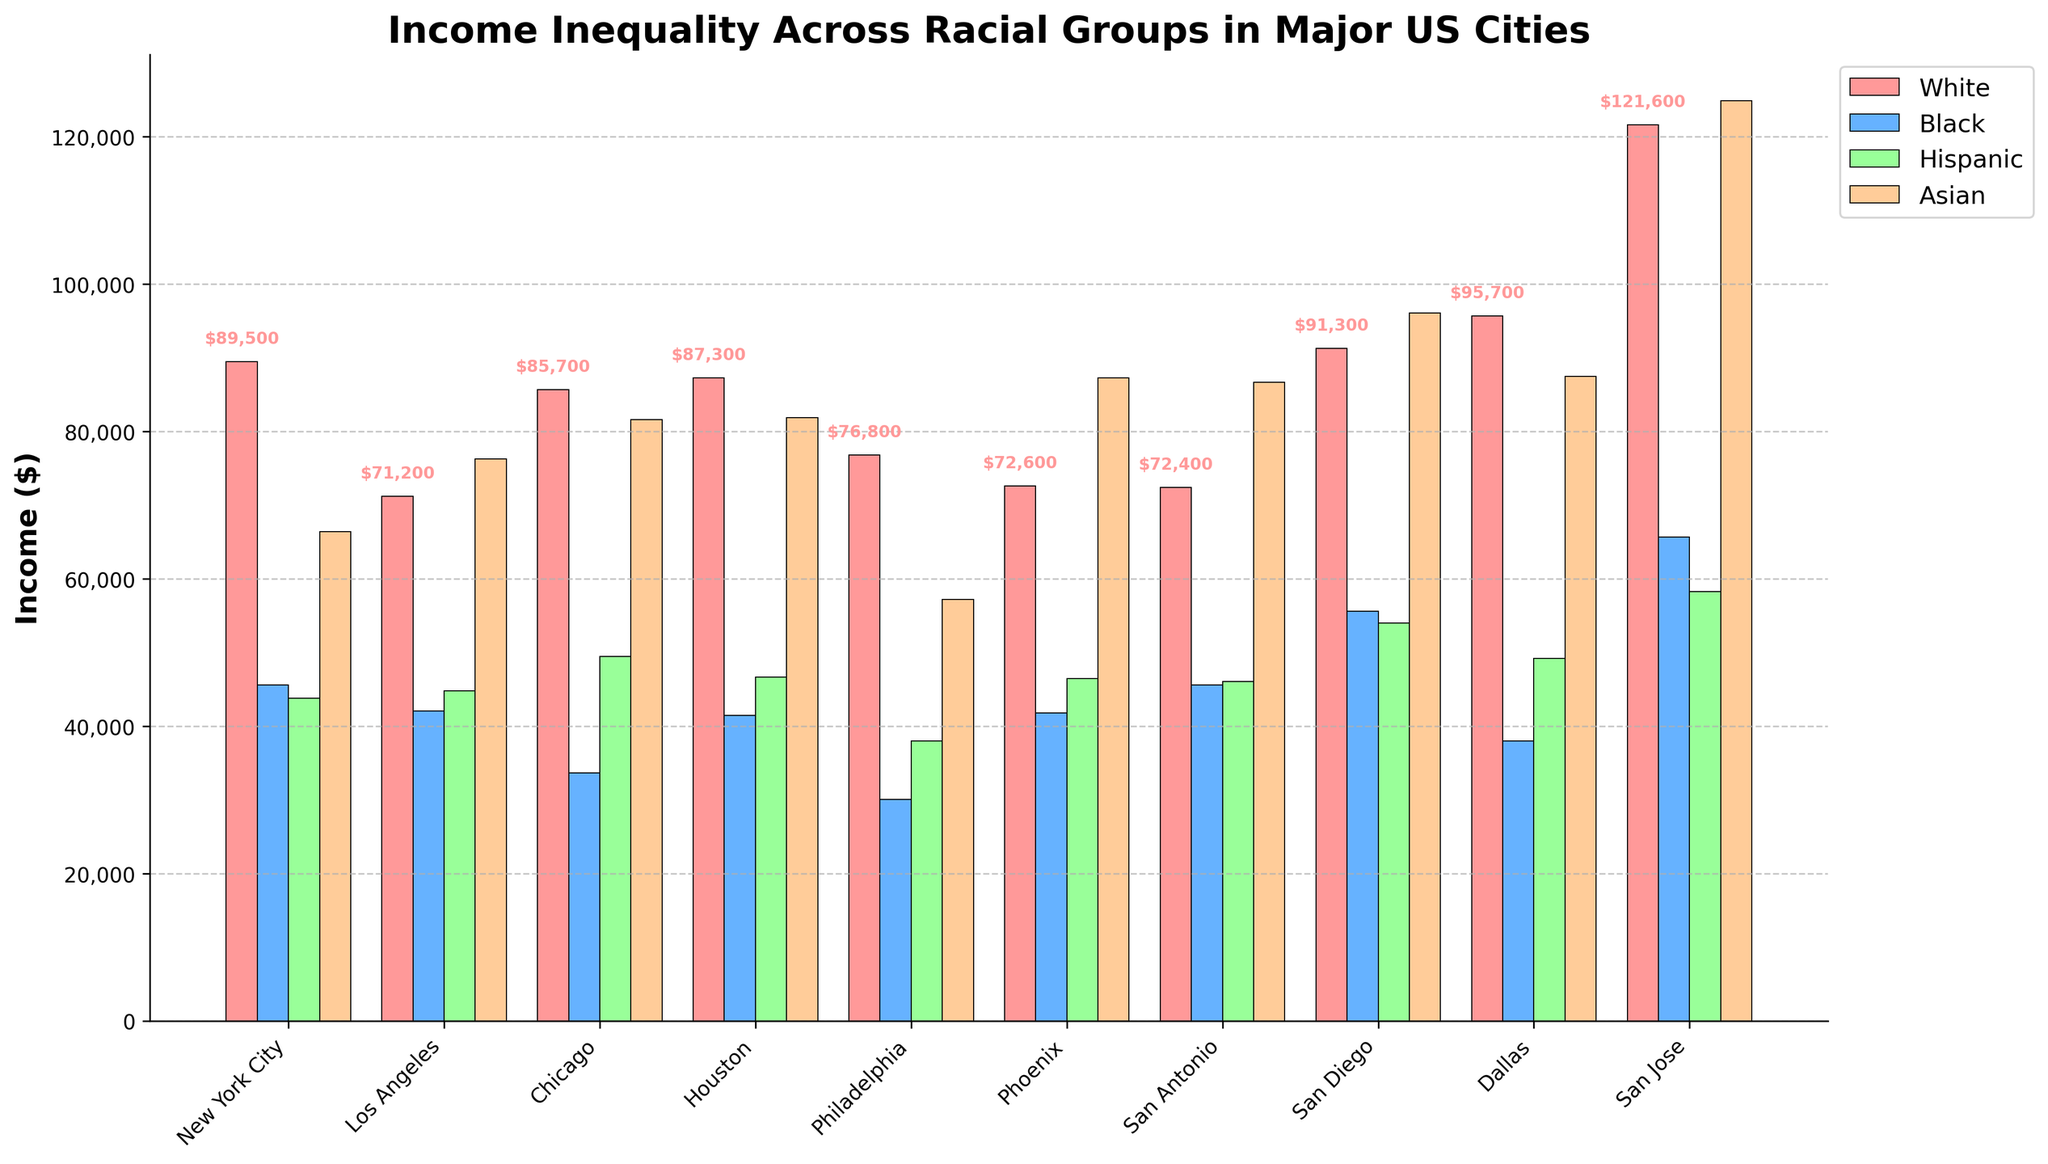What is the difference in median income between White and Black individuals in Chicago? The median incomes for White and Black individuals in Chicago are $85,700 and $33,700, respectively. The difference is calculated as $85,700 - $33,700 = $52,000
Answer: $52,000 Which racial group has the highest average income across all cities displayed? To find the average income across all cities for each racial group, sum the incomes and divide by the number of cities (10). The totals are White: $84,700, Black: $43,360, Hispanic: $46,700, Asian: $86,880. Largest average is for Asian: ($86,880 / 10 = $8,688)
Answer: Asian In Dallas, how much more does the average White individual earn compared to an average Hispanic individual? In Dallas, the income for White and Hispanic individuals are $95,700 and $49,200, respectively. The difference is $95,700 - $49,200 = $46,500
Answer: $46,500 In which city do Asian individuals have the highest income according to the bar chart? San Jose shows the highest income for Asian individuals at $124,900
Answer: San Jose What is the income gap between the highest-paid and lowest-paid group in Philadelphia? In Philadelphia, the highest-paid group is White at $76,800 and the lowest-paid group is Black at $30,100. The gap is $76,800 - $30,100 = $46,700
Answer: $46,700 Which city has the smallest income disparity between White and Black individuals? San Antonio shows a disparity of $72,400 (White) - $45,600 (Black) = $26,800, which is the smallest
Answer: San Antonio What is the average income of White individuals across all the cities? Average income is the total income of White individuals in all cities divided by the number of cities. Total = $857,200. $857,200 / 10 = $85,720
Answer: $85,720 Which racial group in New York City has the highest income, and what is that amount? The group with the highest income in New York City is White, with an income of $89,500
Answer: White, $89,500 Comparing Los Angeles and San Diego, which city has a higher income for Hispanic individuals and what is the difference? Hispanic individuals earn $54,000 in San Diego and $44,800 in Los Angeles. The difference is $54,000 - $44,800 = $9,200
Answer: San Diego, $9,200 How many racial groups in Chicago have an income below $50,000? The racial groups in Chicago with an income below $50,000 are Black ($33,700) and Hispanic ($49,500). Therefore, there are two groups below $50,000
Answer: Two 